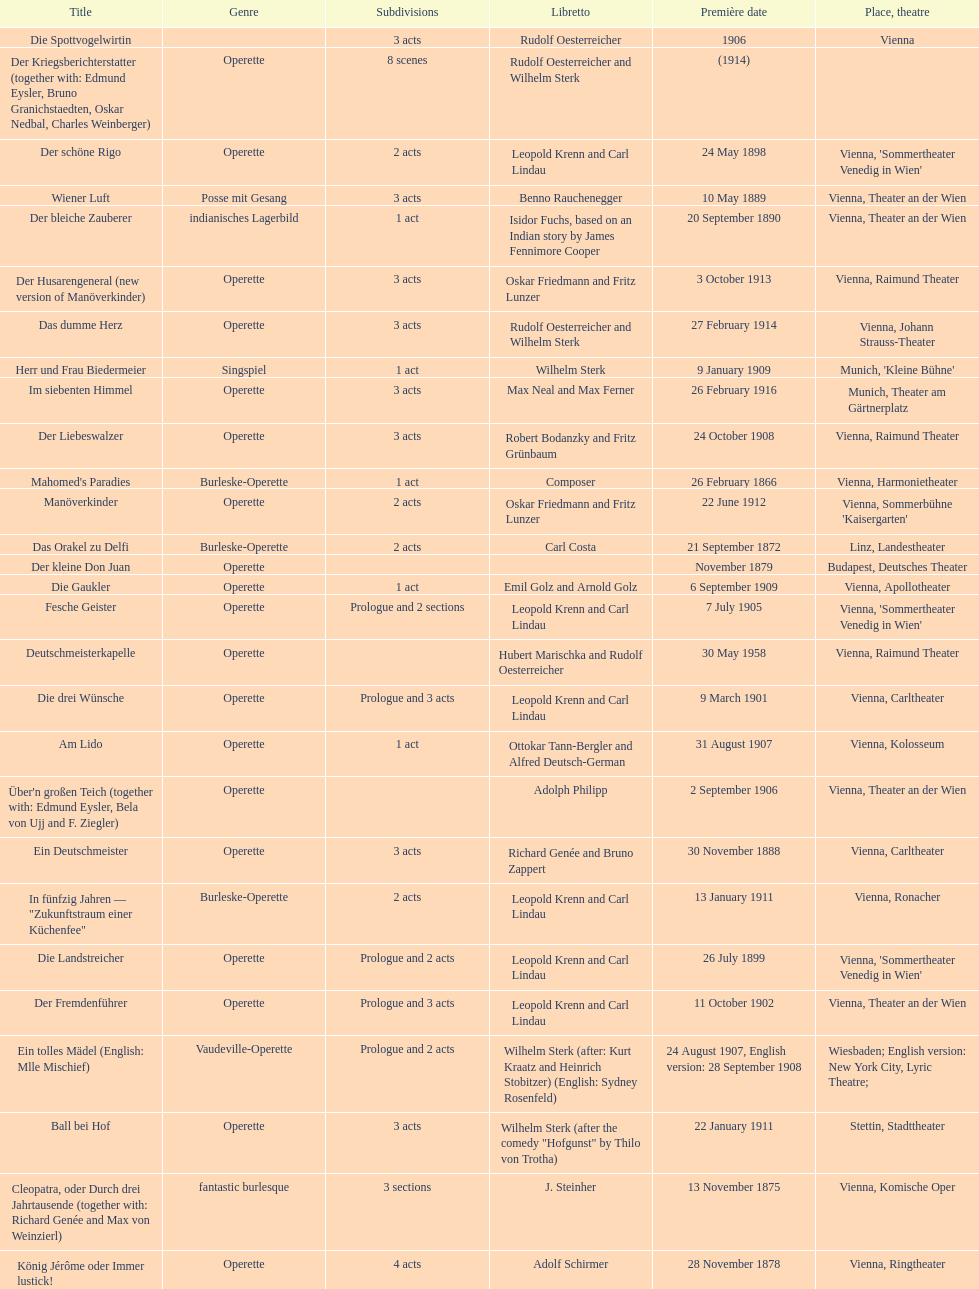How many of his operettas were 3 acts? 13. 